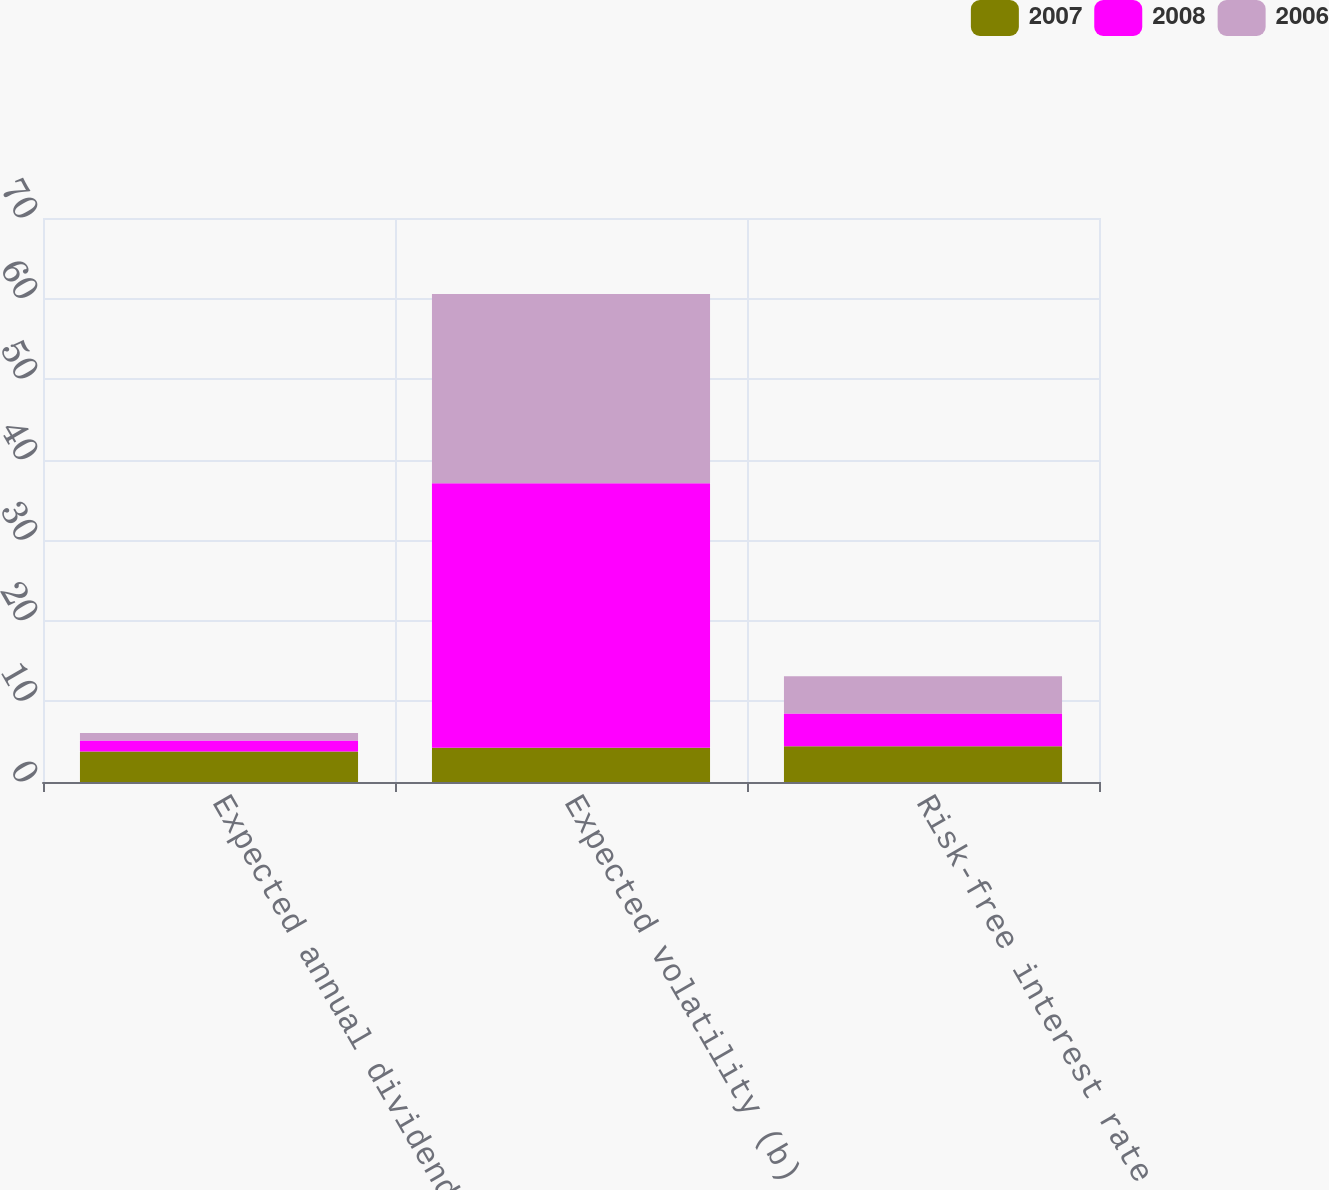<chart> <loc_0><loc_0><loc_500><loc_500><stacked_bar_chart><ecel><fcel>Expected annual dividend yield<fcel>Expected volatility (b)<fcel>Risk-free interest rate (c)<nl><fcel>2007<fcel>3.77<fcel>4.255<fcel>4.43<nl><fcel>2008<fcel>1.39<fcel>32.82<fcel>4.08<nl><fcel>2006<fcel>0.92<fcel>23.5<fcel>4.61<nl></chart> 